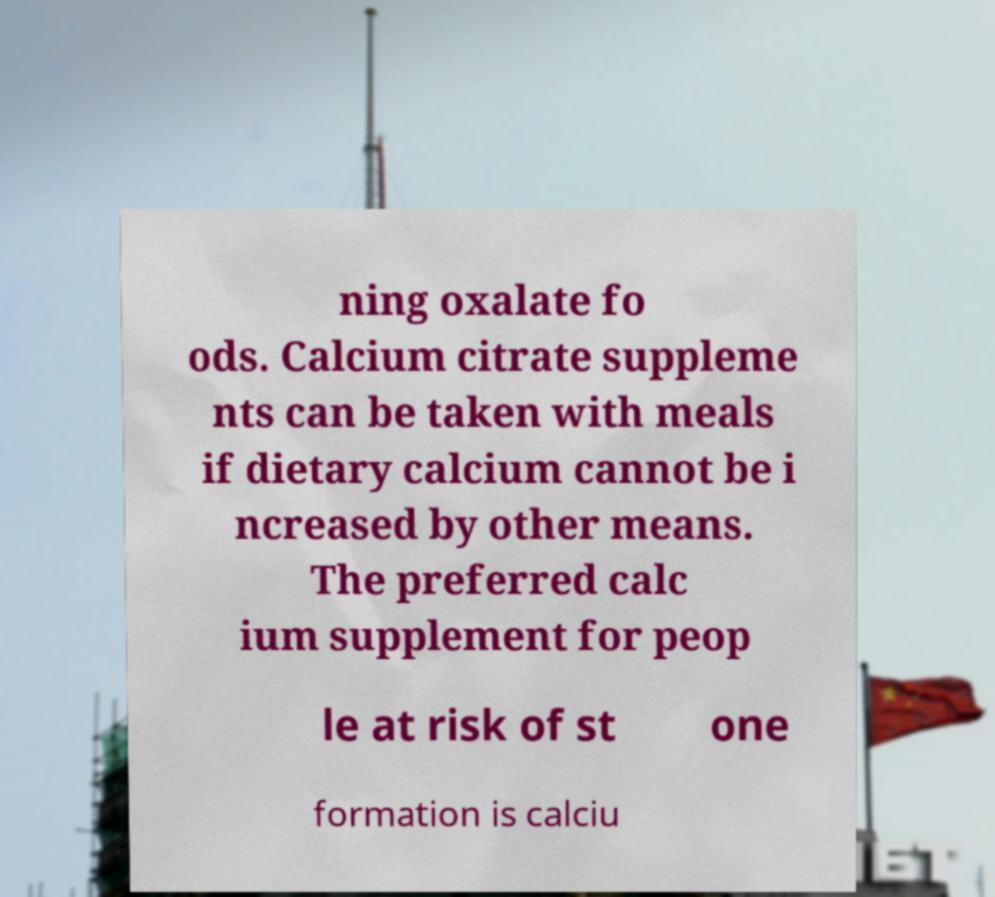Please read and relay the text visible in this image. What does it say? ning oxalate fo ods. Calcium citrate suppleme nts can be taken with meals if dietary calcium cannot be i ncreased by other means. The preferred calc ium supplement for peop le at risk of st one formation is calciu 